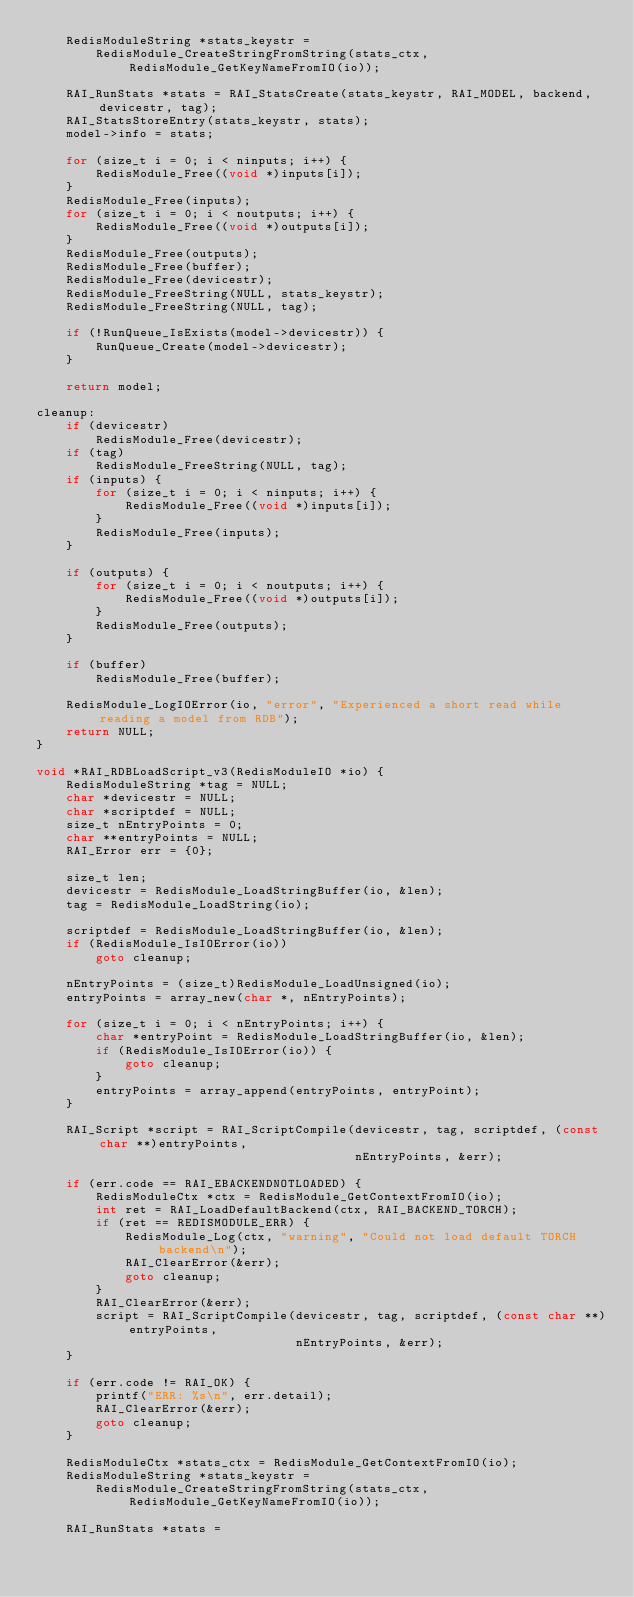<code> <loc_0><loc_0><loc_500><loc_500><_C_>    RedisModuleString *stats_keystr =
        RedisModule_CreateStringFromString(stats_ctx, RedisModule_GetKeyNameFromIO(io));

    RAI_RunStats *stats = RAI_StatsCreate(stats_keystr, RAI_MODEL, backend, devicestr, tag);
    RAI_StatsStoreEntry(stats_keystr, stats);
    model->info = stats;

    for (size_t i = 0; i < ninputs; i++) {
        RedisModule_Free((void *)inputs[i]);
    }
    RedisModule_Free(inputs);
    for (size_t i = 0; i < noutputs; i++) {
        RedisModule_Free((void *)outputs[i]);
    }
    RedisModule_Free(outputs);
    RedisModule_Free(buffer);
    RedisModule_Free(devicestr);
    RedisModule_FreeString(NULL, stats_keystr);
    RedisModule_FreeString(NULL, tag);

    if (!RunQueue_IsExists(model->devicestr)) {
        RunQueue_Create(model->devicestr);
    }

    return model;

cleanup:
    if (devicestr)
        RedisModule_Free(devicestr);
    if (tag)
        RedisModule_FreeString(NULL, tag);
    if (inputs) {
        for (size_t i = 0; i < ninputs; i++) {
            RedisModule_Free((void *)inputs[i]);
        }
        RedisModule_Free(inputs);
    }

    if (outputs) {
        for (size_t i = 0; i < noutputs; i++) {
            RedisModule_Free((void *)outputs[i]);
        }
        RedisModule_Free(outputs);
    }

    if (buffer)
        RedisModule_Free(buffer);

    RedisModule_LogIOError(io, "error", "Experienced a short read while reading a model from RDB");
    return NULL;
}

void *RAI_RDBLoadScript_v3(RedisModuleIO *io) {
    RedisModuleString *tag = NULL;
    char *devicestr = NULL;
    char *scriptdef = NULL;
    size_t nEntryPoints = 0;
    char **entryPoints = NULL;
    RAI_Error err = {0};

    size_t len;
    devicestr = RedisModule_LoadStringBuffer(io, &len);
    tag = RedisModule_LoadString(io);

    scriptdef = RedisModule_LoadStringBuffer(io, &len);
    if (RedisModule_IsIOError(io))
        goto cleanup;

    nEntryPoints = (size_t)RedisModule_LoadUnsigned(io);
    entryPoints = array_new(char *, nEntryPoints);

    for (size_t i = 0; i < nEntryPoints; i++) {
        char *entryPoint = RedisModule_LoadStringBuffer(io, &len);
        if (RedisModule_IsIOError(io)) {
            goto cleanup;
        }
        entryPoints = array_append(entryPoints, entryPoint);
    }

    RAI_Script *script = RAI_ScriptCompile(devicestr, tag, scriptdef, (const char **)entryPoints,
                                           nEntryPoints, &err);

    if (err.code == RAI_EBACKENDNOTLOADED) {
        RedisModuleCtx *ctx = RedisModule_GetContextFromIO(io);
        int ret = RAI_LoadDefaultBackend(ctx, RAI_BACKEND_TORCH);
        if (ret == REDISMODULE_ERR) {
            RedisModule_Log(ctx, "warning", "Could not load default TORCH backend\n");
            RAI_ClearError(&err);
            goto cleanup;
        }
        RAI_ClearError(&err);
        script = RAI_ScriptCompile(devicestr, tag, scriptdef, (const char **)entryPoints,
                                   nEntryPoints, &err);
    }

    if (err.code != RAI_OK) {
        printf("ERR: %s\n", err.detail);
        RAI_ClearError(&err);
        goto cleanup;
    }

    RedisModuleCtx *stats_ctx = RedisModule_GetContextFromIO(io);
    RedisModuleString *stats_keystr =
        RedisModule_CreateStringFromString(stats_ctx, RedisModule_GetKeyNameFromIO(io));

    RAI_RunStats *stats =</code> 